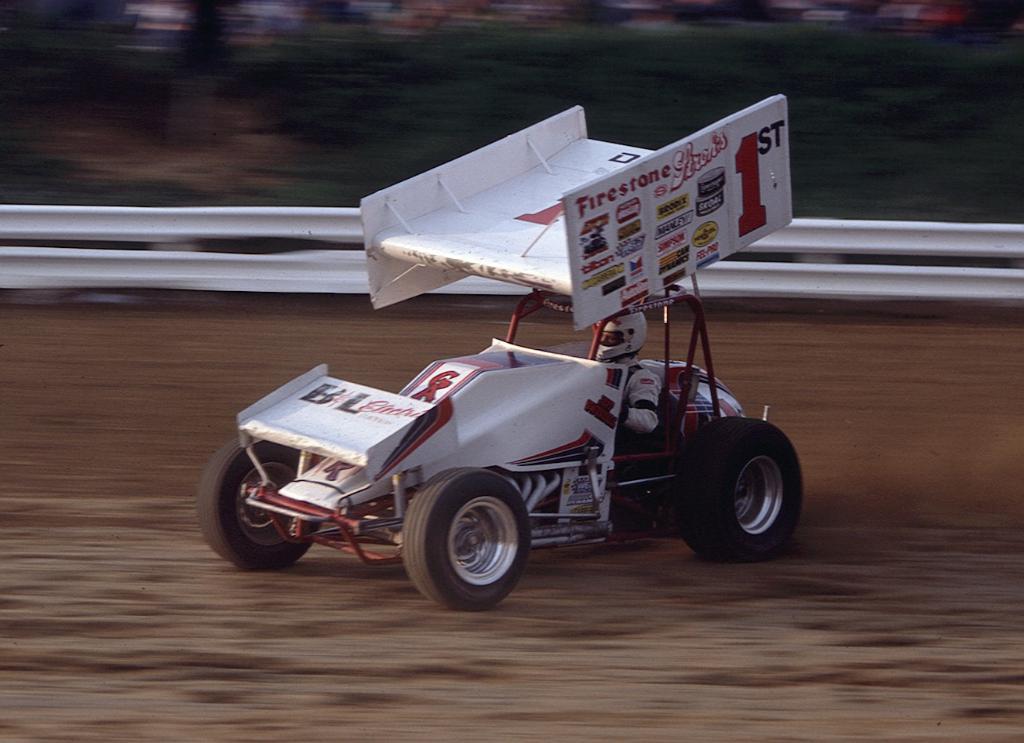What number is this car?
Make the answer very short. 1. The car number is 1?
Provide a succinct answer. Yes. 